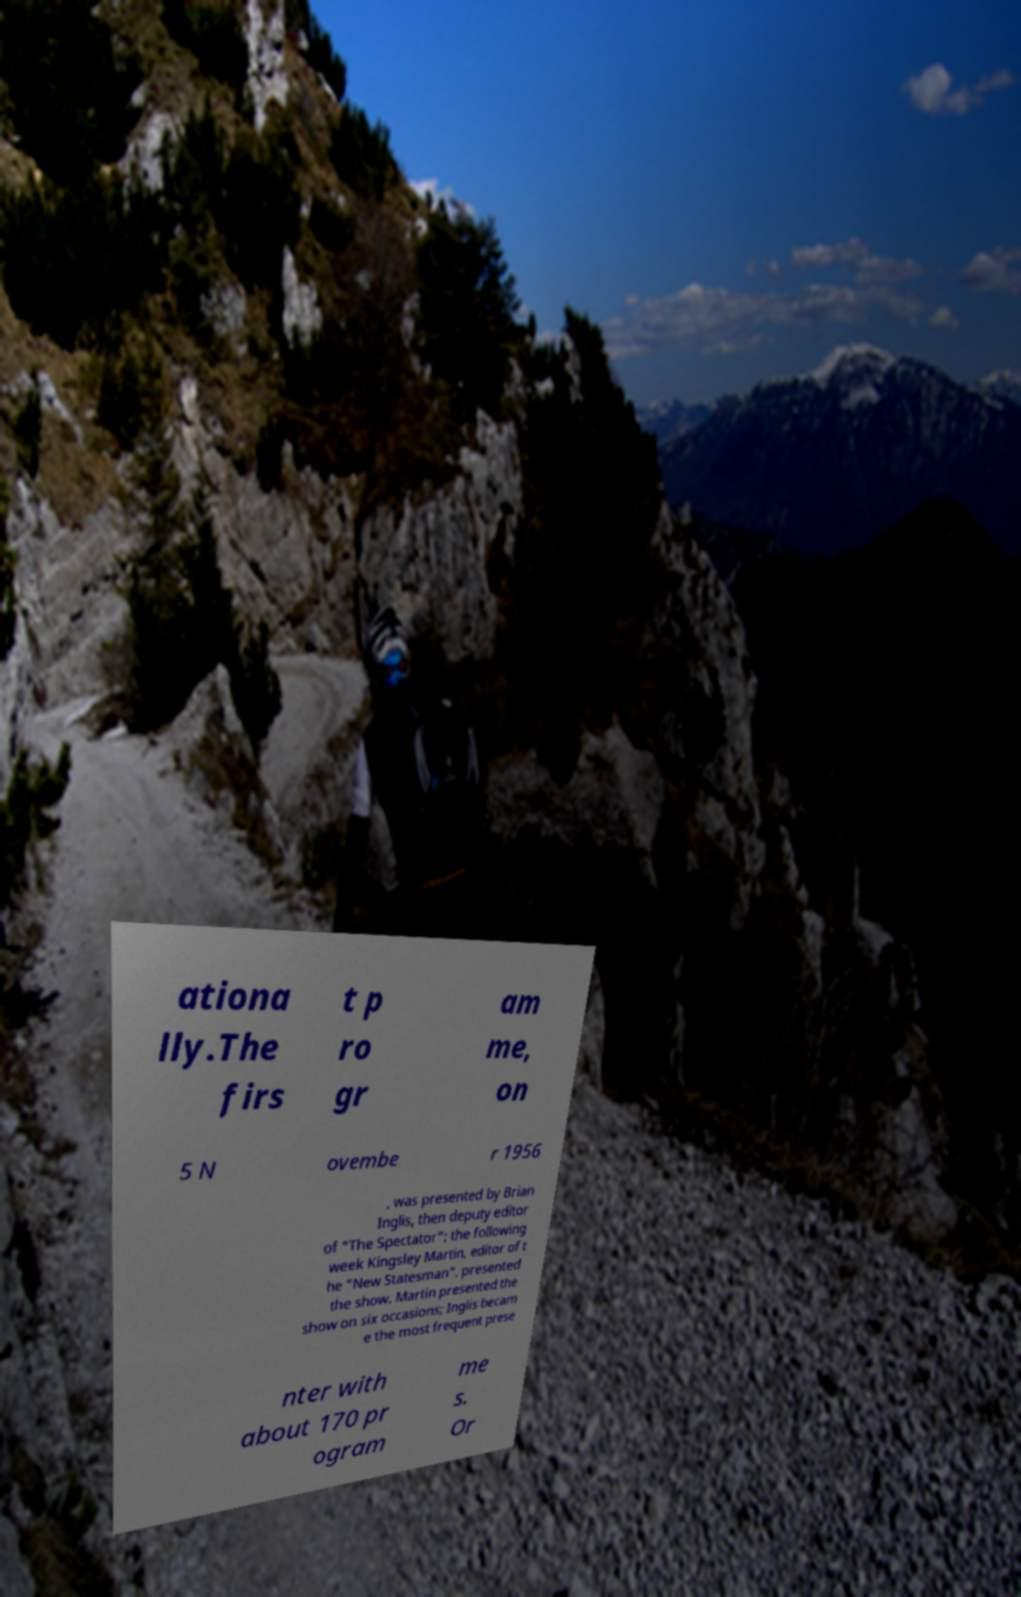Can you read and provide the text displayed in the image?This photo seems to have some interesting text. Can you extract and type it out for me? ationa lly.The firs t p ro gr am me, on 5 N ovembe r 1956 , was presented by Brian Inglis, then deputy editor of "The Spectator"; the following week Kingsley Martin, editor of t he "New Statesman", presented the show. Martin presented the show on six occasions; Inglis becam e the most frequent prese nter with about 170 pr ogram me s. Or 